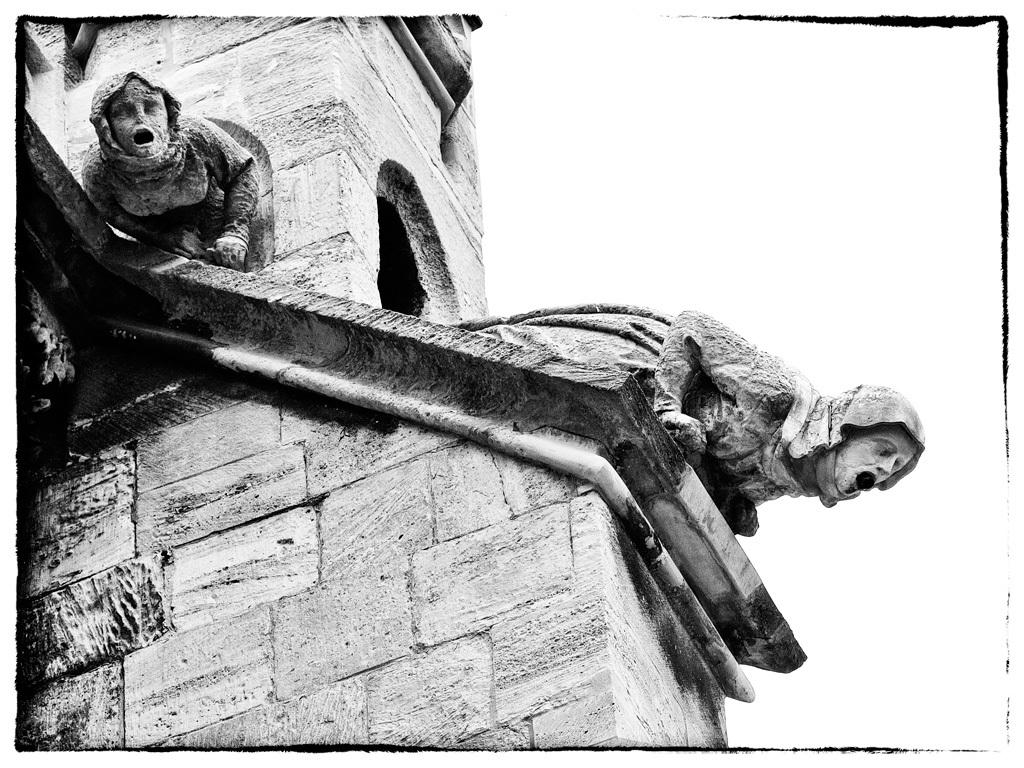What is the main structure in the image? There is a monument in the image. What can be seen on either side of the monument? There are statues of persons on the right and left sides of the monument. Is there any architectural feature that allows for visibility into the monument? Yes, there is a window in the image. What part of the sky is visible in the image? The sky is visible at the top right of the image. What type of watch can be seen in the pocket of one of the statues in the image? There are no watches or pockets visible on the statues in the image. 